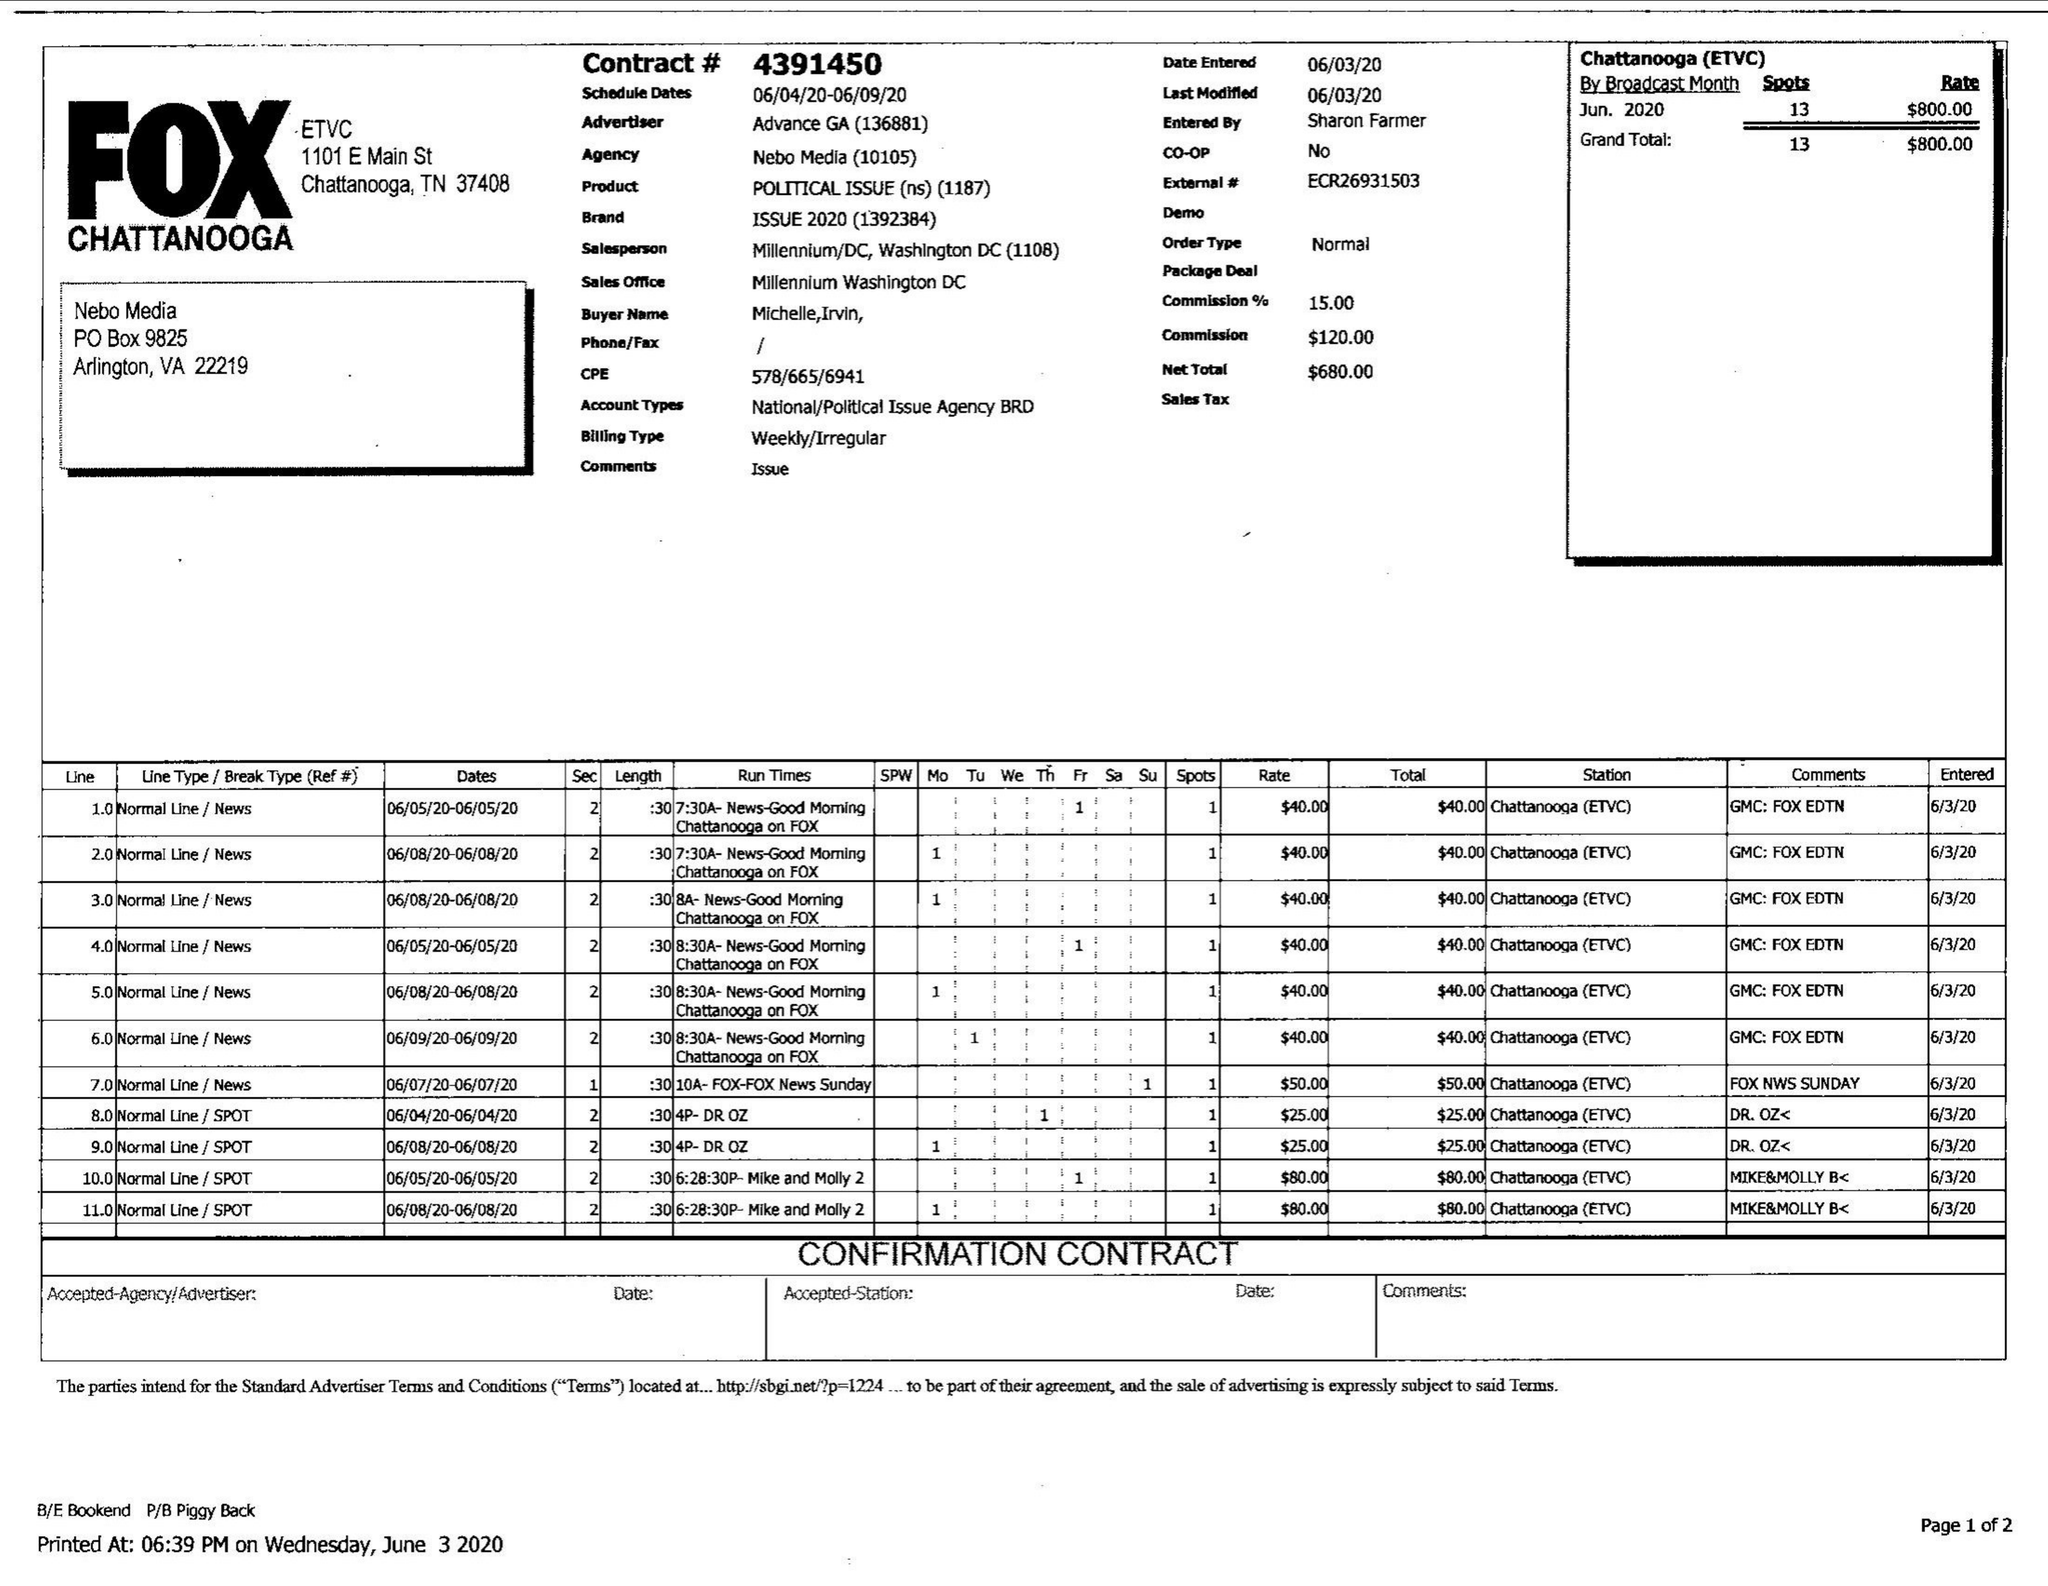What is the value for the flight_from?
Answer the question using a single word or phrase. 06/04/20 